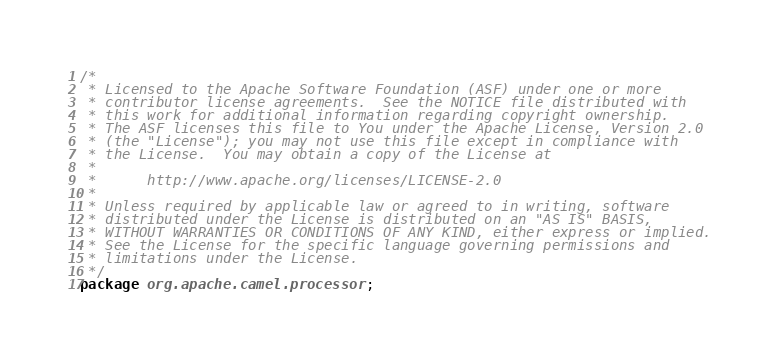<code> <loc_0><loc_0><loc_500><loc_500><_Java_>/*
 * Licensed to the Apache Software Foundation (ASF) under one or more
 * contributor license agreements.  See the NOTICE file distributed with
 * this work for additional information regarding copyright ownership.
 * The ASF licenses this file to You under the Apache License, Version 2.0
 * (the "License"); you may not use this file except in compliance with
 * the License.  You may obtain a copy of the License at
 *
 *      http://www.apache.org/licenses/LICENSE-2.0
 *
 * Unless required by applicable law or agreed to in writing, software
 * distributed under the License is distributed on an "AS IS" BASIS,
 * WITHOUT WARRANTIES OR CONDITIONS OF ANY KIND, either express or implied.
 * See the License for the specific language governing permissions and
 * limitations under the License.
 */
package org.apache.camel.processor;
</code> 